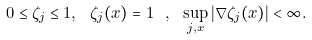<formula> <loc_0><loc_0><loc_500><loc_500>0 \leq \zeta _ { j } \leq 1 , \ \zeta _ { j } ( x ) = 1 \ , \ \sup _ { j , x } | \nabla \zeta _ { j } ( x ) | < \infty .</formula> 